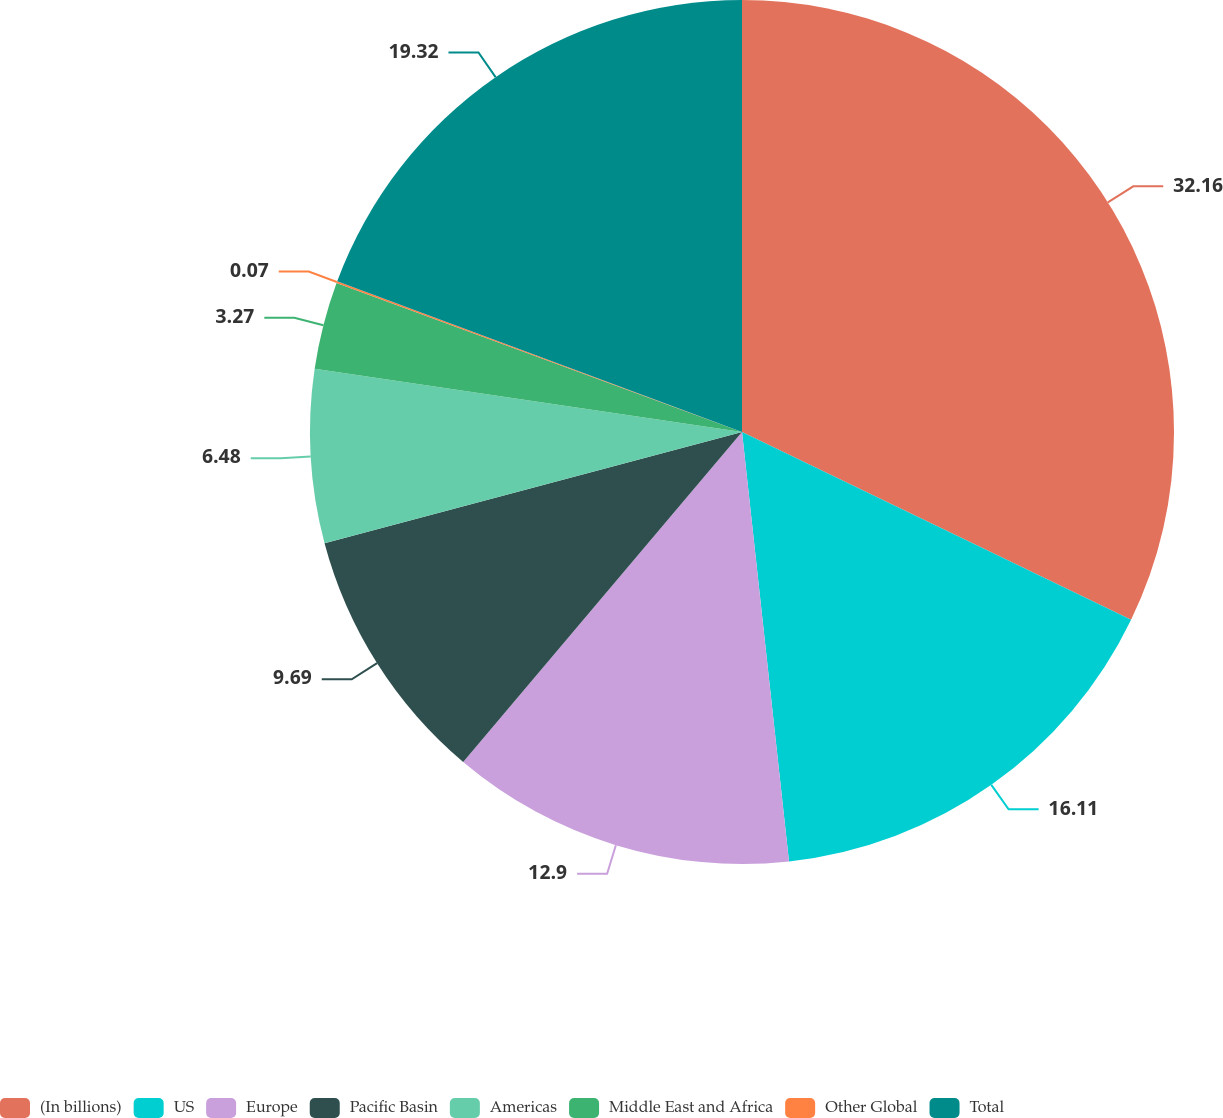Convert chart. <chart><loc_0><loc_0><loc_500><loc_500><pie_chart><fcel>(In billions)<fcel>US<fcel>Europe<fcel>Pacific Basin<fcel>Americas<fcel>Middle East and Africa<fcel>Other Global<fcel>Total<nl><fcel>32.15%<fcel>16.11%<fcel>12.9%<fcel>9.69%<fcel>6.48%<fcel>3.27%<fcel>0.07%<fcel>19.32%<nl></chart> 